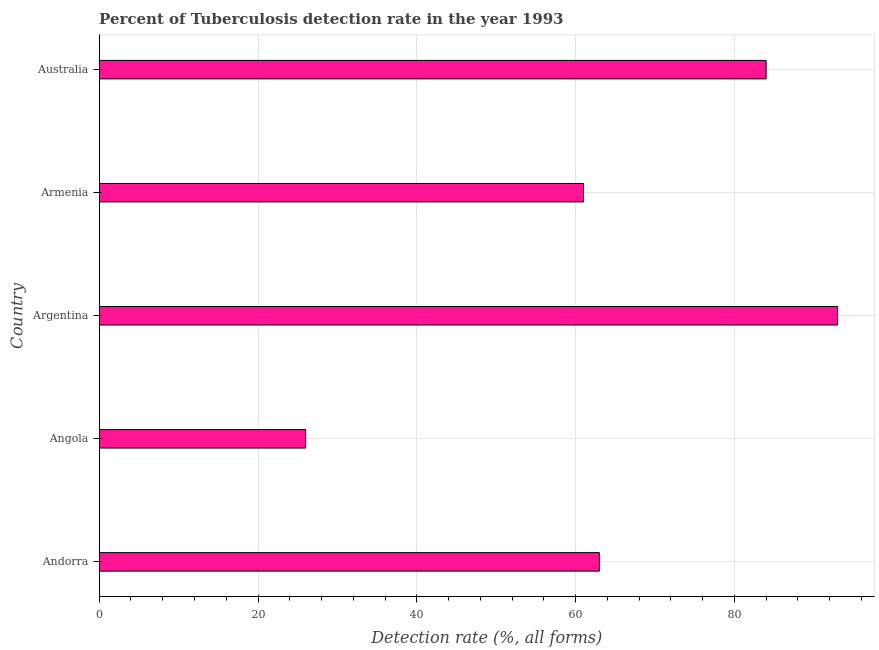Does the graph contain grids?
Offer a terse response. Yes. What is the title of the graph?
Give a very brief answer. Percent of Tuberculosis detection rate in the year 1993. What is the label or title of the X-axis?
Your answer should be very brief. Detection rate (%, all forms). What is the label or title of the Y-axis?
Provide a short and direct response. Country. What is the detection rate of tuberculosis in Armenia?
Offer a terse response. 61. Across all countries, what is the maximum detection rate of tuberculosis?
Your answer should be very brief. 93. Across all countries, what is the minimum detection rate of tuberculosis?
Your answer should be very brief. 26. In which country was the detection rate of tuberculosis maximum?
Your answer should be very brief. Argentina. In which country was the detection rate of tuberculosis minimum?
Provide a short and direct response. Angola. What is the sum of the detection rate of tuberculosis?
Give a very brief answer. 327. What is the average detection rate of tuberculosis per country?
Offer a terse response. 65.4. What is the median detection rate of tuberculosis?
Keep it short and to the point. 63. In how many countries, is the detection rate of tuberculosis greater than 56 %?
Your answer should be compact. 4. What is the ratio of the detection rate of tuberculosis in Andorra to that in Argentina?
Ensure brevity in your answer.  0.68. Is the detection rate of tuberculosis in Angola less than that in Argentina?
Make the answer very short. Yes. What is the difference between the highest and the lowest detection rate of tuberculosis?
Provide a short and direct response. 67. How many bars are there?
Provide a short and direct response. 5. What is the difference between two consecutive major ticks on the X-axis?
Your answer should be very brief. 20. What is the Detection rate (%, all forms) in Andorra?
Your response must be concise. 63. What is the Detection rate (%, all forms) of Argentina?
Provide a short and direct response. 93. What is the Detection rate (%, all forms) of Armenia?
Ensure brevity in your answer.  61. What is the difference between the Detection rate (%, all forms) in Andorra and Argentina?
Provide a short and direct response. -30. What is the difference between the Detection rate (%, all forms) in Andorra and Australia?
Your response must be concise. -21. What is the difference between the Detection rate (%, all forms) in Angola and Argentina?
Keep it short and to the point. -67. What is the difference between the Detection rate (%, all forms) in Angola and Armenia?
Offer a very short reply. -35. What is the difference between the Detection rate (%, all forms) in Angola and Australia?
Your response must be concise. -58. What is the ratio of the Detection rate (%, all forms) in Andorra to that in Angola?
Your answer should be compact. 2.42. What is the ratio of the Detection rate (%, all forms) in Andorra to that in Argentina?
Offer a very short reply. 0.68. What is the ratio of the Detection rate (%, all forms) in Andorra to that in Armenia?
Provide a succinct answer. 1.03. What is the ratio of the Detection rate (%, all forms) in Andorra to that in Australia?
Your answer should be very brief. 0.75. What is the ratio of the Detection rate (%, all forms) in Angola to that in Argentina?
Keep it short and to the point. 0.28. What is the ratio of the Detection rate (%, all forms) in Angola to that in Armenia?
Ensure brevity in your answer.  0.43. What is the ratio of the Detection rate (%, all forms) in Angola to that in Australia?
Provide a succinct answer. 0.31. What is the ratio of the Detection rate (%, all forms) in Argentina to that in Armenia?
Provide a short and direct response. 1.52. What is the ratio of the Detection rate (%, all forms) in Argentina to that in Australia?
Your answer should be compact. 1.11. What is the ratio of the Detection rate (%, all forms) in Armenia to that in Australia?
Your answer should be very brief. 0.73. 